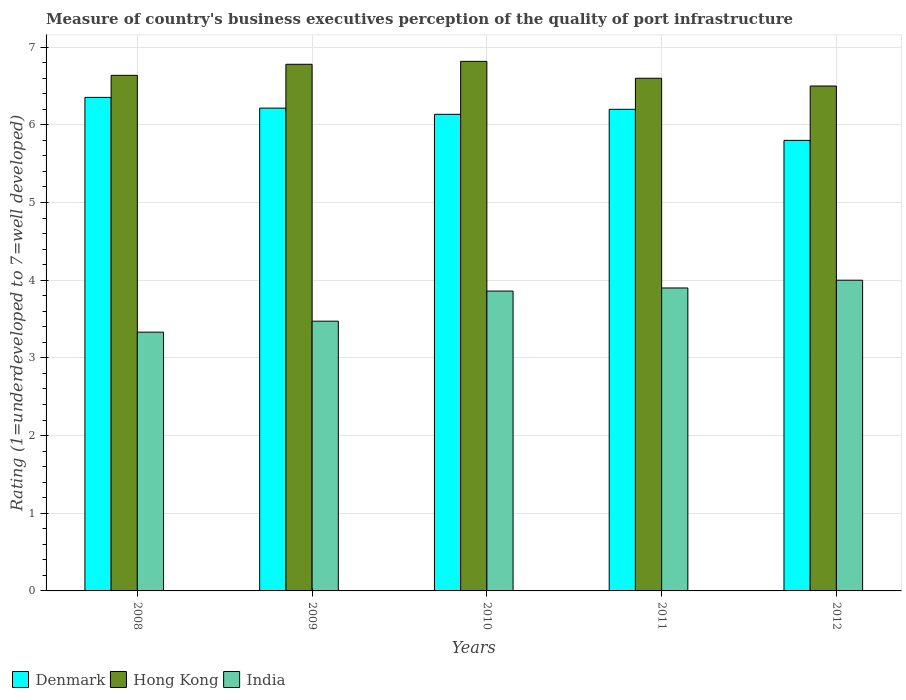How many groups of bars are there?
Make the answer very short. 5. Are the number of bars per tick equal to the number of legend labels?
Provide a succinct answer. Yes. How many bars are there on the 3rd tick from the right?
Make the answer very short. 3. What is the ratings of the quality of port infrastructure in Hong Kong in 2008?
Your answer should be very brief. 6.64. Across all years, what is the maximum ratings of the quality of port infrastructure in Denmark?
Your answer should be compact. 6.35. Across all years, what is the minimum ratings of the quality of port infrastructure in Hong Kong?
Offer a terse response. 6.5. In which year was the ratings of the quality of port infrastructure in Denmark maximum?
Make the answer very short. 2008. What is the total ratings of the quality of port infrastructure in Denmark in the graph?
Ensure brevity in your answer.  30.7. What is the difference between the ratings of the quality of port infrastructure in Denmark in 2008 and that in 2011?
Your answer should be very brief. 0.15. What is the difference between the ratings of the quality of port infrastructure in Denmark in 2009 and the ratings of the quality of port infrastructure in Hong Kong in 2012?
Keep it short and to the point. -0.28. What is the average ratings of the quality of port infrastructure in Hong Kong per year?
Make the answer very short. 6.67. In the year 2011, what is the difference between the ratings of the quality of port infrastructure in Hong Kong and ratings of the quality of port infrastructure in India?
Your response must be concise. 2.7. In how many years, is the ratings of the quality of port infrastructure in India greater than 2?
Keep it short and to the point. 5. What is the ratio of the ratings of the quality of port infrastructure in Hong Kong in 2009 to that in 2012?
Ensure brevity in your answer.  1.04. Is the ratings of the quality of port infrastructure in Hong Kong in 2011 less than that in 2012?
Make the answer very short. No. Is the difference between the ratings of the quality of port infrastructure in Hong Kong in 2008 and 2010 greater than the difference between the ratings of the quality of port infrastructure in India in 2008 and 2010?
Provide a short and direct response. Yes. What is the difference between the highest and the second highest ratings of the quality of port infrastructure in Hong Kong?
Offer a terse response. 0.04. What is the difference between the highest and the lowest ratings of the quality of port infrastructure in India?
Your answer should be compact. 0.67. What does the 1st bar from the left in 2009 represents?
Ensure brevity in your answer.  Denmark. What does the 1st bar from the right in 2012 represents?
Offer a terse response. India. Is it the case that in every year, the sum of the ratings of the quality of port infrastructure in Denmark and ratings of the quality of port infrastructure in Hong Kong is greater than the ratings of the quality of port infrastructure in India?
Your response must be concise. Yes. Are all the bars in the graph horizontal?
Your response must be concise. No. How many years are there in the graph?
Provide a short and direct response. 5. Does the graph contain any zero values?
Ensure brevity in your answer.  No. Does the graph contain grids?
Offer a terse response. Yes. Where does the legend appear in the graph?
Keep it short and to the point. Bottom left. What is the title of the graph?
Offer a terse response. Measure of country's business executives perception of the quality of port infrastructure. Does "High income: nonOECD" appear as one of the legend labels in the graph?
Make the answer very short. No. What is the label or title of the X-axis?
Your answer should be very brief. Years. What is the label or title of the Y-axis?
Ensure brevity in your answer.  Rating (1=underdeveloped to 7=well developed). What is the Rating (1=underdeveloped to 7=well developed) in Denmark in 2008?
Offer a terse response. 6.35. What is the Rating (1=underdeveloped to 7=well developed) in Hong Kong in 2008?
Your response must be concise. 6.64. What is the Rating (1=underdeveloped to 7=well developed) in India in 2008?
Give a very brief answer. 3.33. What is the Rating (1=underdeveloped to 7=well developed) in Denmark in 2009?
Ensure brevity in your answer.  6.22. What is the Rating (1=underdeveloped to 7=well developed) of Hong Kong in 2009?
Offer a very short reply. 6.78. What is the Rating (1=underdeveloped to 7=well developed) of India in 2009?
Keep it short and to the point. 3.47. What is the Rating (1=underdeveloped to 7=well developed) in Denmark in 2010?
Provide a succinct answer. 6.14. What is the Rating (1=underdeveloped to 7=well developed) of Hong Kong in 2010?
Make the answer very short. 6.82. What is the Rating (1=underdeveloped to 7=well developed) of India in 2010?
Keep it short and to the point. 3.86. What is the Rating (1=underdeveloped to 7=well developed) in Denmark in 2011?
Make the answer very short. 6.2. What is the Rating (1=underdeveloped to 7=well developed) of India in 2011?
Offer a terse response. 3.9. Across all years, what is the maximum Rating (1=underdeveloped to 7=well developed) of Denmark?
Your response must be concise. 6.35. Across all years, what is the maximum Rating (1=underdeveloped to 7=well developed) in Hong Kong?
Your response must be concise. 6.82. Across all years, what is the minimum Rating (1=underdeveloped to 7=well developed) in India?
Give a very brief answer. 3.33. What is the total Rating (1=underdeveloped to 7=well developed) of Denmark in the graph?
Give a very brief answer. 30.7. What is the total Rating (1=underdeveloped to 7=well developed) in Hong Kong in the graph?
Provide a succinct answer. 33.33. What is the total Rating (1=underdeveloped to 7=well developed) of India in the graph?
Your answer should be very brief. 18.56. What is the difference between the Rating (1=underdeveloped to 7=well developed) in Denmark in 2008 and that in 2009?
Your response must be concise. 0.14. What is the difference between the Rating (1=underdeveloped to 7=well developed) of Hong Kong in 2008 and that in 2009?
Offer a very short reply. -0.14. What is the difference between the Rating (1=underdeveloped to 7=well developed) of India in 2008 and that in 2009?
Offer a terse response. -0.14. What is the difference between the Rating (1=underdeveloped to 7=well developed) in Denmark in 2008 and that in 2010?
Make the answer very short. 0.22. What is the difference between the Rating (1=underdeveloped to 7=well developed) in Hong Kong in 2008 and that in 2010?
Offer a very short reply. -0.18. What is the difference between the Rating (1=underdeveloped to 7=well developed) in India in 2008 and that in 2010?
Your answer should be compact. -0.53. What is the difference between the Rating (1=underdeveloped to 7=well developed) in Denmark in 2008 and that in 2011?
Your answer should be very brief. 0.15. What is the difference between the Rating (1=underdeveloped to 7=well developed) of Hong Kong in 2008 and that in 2011?
Your answer should be compact. 0.04. What is the difference between the Rating (1=underdeveloped to 7=well developed) of India in 2008 and that in 2011?
Ensure brevity in your answer.  -0.57. What is the difference between the Rating (1=underdeveloped to 7=well developed) in Denmark in 2008 and that in 2012?
Ensure brevity in your answer.  0.55. What is the difference between the Rating (1=underdeveloped to 7=well developed) of Hong Kong in 2008 and that in 2012?
Make the answer very short. 0.14. What is the difference between the Rating (1=underdeveloped to 7=well developed) of India in 2008 and that in 2012?
Offer a terse response. -0.67. What is the difference between the Rating (1=underdeveloped to 7=well developed) in Denmark in 2009 and that in 2010?
Provide a short and direct response. 0.08. What is the difference between the Rating (1=underdeveloped to 7=well developed) in Hong Kong in 2009 and that in 2010?
Provide a succinct answer. -0.04. What is the difference between the Rating (1=underdeveloped to 7=well developed) of India in 2009 and that in 2010?
Your answer should be compact. -0.39. What is the difference between the Rating (1=underdeveloped to 7=well developed) in Denmark in 2009 and that in 2011?
Ensure brevity in your answer.  0.02. What is the difference between the Rating (1=underdeveloped to 7=well developed) in Hong Kong in 2009 and that in 2011?
Make the answer very short. 0.18. What is the difference between the Rating (1=underdeveloped to 7=well developed) in India in 2009 and that in 2011?
Make the answer very short. -0.43. What is the difference between the Rating (1=underdeveloped to 7=well developed) in Denmark in 2009 and that in 2012?
Provide a succinct answer. 0.42. What is the difference between the Rating (1=underdeveloped to 7=well developed) in Hong Kong in 2009 and that in 2012?
Your answer should be very brief. 0.28. What is the difference between the Rating (1=underdeveloped to 7=well developed) of India in 2009 and that in 2012?
Ensure brevity in your answer.  -0.53. What is the difference between the Rating (1=underdeveloped to 7=well developed) in Denmark in 2010 and that in 2011?
Give a very brief answer. -0.06. What is the difference between the Rating (1=underdeveloped to 7=well developed) in Hong Kong in 2010 and that in 2011?
Your answer should be compact. 0.22. What is the difference between the Rating (1=underdeveloped to 7=well developed) in India in 2010 and that in 2011?
Give a very brief answer. -0.04. What is the difference between the Rating (1=underdeveloped to 7=well developed) in Denmark in 2010 and that in 2012?
Offer a terse response. 0.34. What is the difference between the Rating (1=underdeveloped to 7=well developed) of Hong Kong in 2010 and that in 2012?
Make the answer very short. 0.32. What is the difference between the Rating (1=underdeveloped to 7=well developed) in India in 2010 and that in 2012?
Offer a very short reply. -0.14. What is the difference between the Rating (1=underdeveloped to 7=well developed) of Denmark in 2011 and that in 2012?
Offer a very short reply. 0.4. What is the difference between the Rating (1=underdeveloped to 7=well developed) in India in 2011 and that in 2012?
Offer a very short reply. -0.1. What is the difference between the Rating (1=underdeveloped to 7=well developed) of Denmark in 2008 and the Rating (1=underdeveloped to 7=well developed) of Hong Kong in 2009?
Your answer should be very brief. -0.43. What is the difference between the Rating (1=underdeveloped to 7=well developed) in Denmark in 2008 and the Rating (1=underdeveloped to 7=well developed) in India in 2009?
Keep it short and to the point. 2.88. What is the difference between the Rating (1=underdeveloped to 7=well developed) in Hong Kong in 2008 and the Rating (1=underdeveloped to 7=well developed) in India in 2009?
Provide a succinct answer. 3.16. What is the difference between the Rating (1=underdeveloped to 7=well developed) in Denmark in 2008 and the Rating (1=underdeveloped to 7=well developed) in Hong Kong in 2010?
Ensure brevity in your answer.  -0.46. What is the difference between the Rating (1=underdeveloped to 7=well developed) of Denmark in 2008 and the Rating (1=underdeveloped to 7=well developed) of India in 2010?
Your answer should be compact. 2.49. What is the difference between the Rating (1=underdeveloped to 7=well developed) of Hong Kong in 2008 and the Rating (1=underdeveloped to 7=well developed) of India in 2010?
Offer a very short reply. 2.78. What is the difference between the Rating (1=underdeveloped to 7=well developed) of Denmark in 2008 and the Rating (1=underdeveloped to 7=well developed) of Hong Kong in 2011?
Provide a short and direct response. -0.25. What is the difference between the Rating (1=underdeveloped to 7=well developed) in Denmark in 2008 and the Rating (1=underdeveloped to 7=well developed) in India in 2011?
Your answer should be very brief. 2.45. What is the difference between the Rating (1=underdeveloped to 7=well developed) in Hong Kong in 2008 and the Rating (1=underdeveloped to 7=well developed) in India in 2011?
Your answer should be very brief. 2.74. What is the difference between the Rating (1=underdeveloped to 7=well developed) in Denmark in 2008 and the Rating (1=underdeveloped to 7=well developed) in Hong Kong in 2012?
Provide a short and direct response. -0.15. What is the difference between the Rating (1=underdeveloped to 7=well developed) of Denmark in 2008 and the Rating (1=underdeveloped to 7=well developed) of India in 2012?
Keep it short and to the point. 2.35. What is the difference between the Rating (1=underdeveloped to 7=well developed) of Hong Kong in 2008 and the Rating (1=underdeveloped to 7=well developed) of India in 2012?
Your answer should be compact. 2.64. What is the difference between the Rating (1=underdeveloped to 7=well developed) in Denmark in 2009 and the Rating (1=underdeveloped to 7=well developed) in Hong Kong in 2010?
Keep it short and to the point. -0.6. What is the difference between the Rating (1=underdeveloped to 7=well developed) in Denmark in 2009 and the Rating (1=underdeveloped to 7=well developed) in India in 2010?
Your response must be concise. 2.35. What is the difference between the Rating (1=underdeveloped to 7=well developed) of Hong Kong in 2009 and the Rating (1=underdeveloped to 7=well developed) of India in 2010?
Your answer should be very brief. 2.92. What is the difference between the Rating (1=underdeveloped to 7=well developed) in Denmark in 2009 and the Rating (1=underdeveloped to 7=well developed) in Hong Kong in 2011?
Make the answer very short. -0.38. What is the difference between the Rating (1=underdeveloped to 7=well developed) of Denmark in 2009 and the Rating (1=underdeveloped to 7=well developed) of India in 2011?
Provide a succinct answer. 2.32. What is the difference between the Rating (1=underdeveloped to 7=well developed) in Hong Kong in 2009 and the Rating (1=underdeveloped to 7=well developed) in India in 2011?
Your response must be concise. 2.88. What is the difference between the Rating (1=underdeveloped to 7=well developed) in Denmark in 2009 and the Rating (1=underdeveloped to 7=well developed) in Hong Kong in 2012?
Provide a succinct answer. -0.28. What is the difference between the Rating (1=underdeveloped to 7=well developed) in Denmark in 2009 and the Rating (1=underdeveloped to 7=well developed) in India in 2012?
Your response must be concise. 2.22. What is the difference between the Rating (1=underdeveloped to 7=well developed) of Hong Kong in 2009 and the Rating (1=underdeveloped to 7=well developed) of India in 2012?
Your answer should be compact. 2.78. What is the difference between the Rating (1=underdeveloped to 7=well developed) in Denmark in 2010 and the Rating (1=underdeveloped to 7=well developed) in Hong Kong in 2011?
Offer a terse response. -0.46. What is the difference between the Rating (1=underdeveloped to 7=well developed) in Denmark in 2010 and the Rating (1=underdeveloped to 7=well developed) in India in 2011?
Keep it short and to the point. 2.24. What is the difference between the Rating (1=underdeveloped to 7=well developed) in Hong Kong in 2010 and the Rating (1=underdeveloped to 7=well developed) in India in 2011?
Ensure brevity in your answer.  2.92. What is the difference between the Rating (1=underdeveloped to 7=well developed) of Denmark in 2010 and the Rating (1=underdeveloped to 7=well developed) of Hong Kong in 2012?
Offer a very short reply. -0.36. What is the difference between the Rating (1=underdeveloped to 7=well developed) in Denmark in 2010 and the Rating (1=underdeveloped to 7=well developed) in India in 2012?
Your answer should be very brief. 2.14. What is the difference between the Rating (1=underdeveloped to 7=well developed) of Hong Kong in 2010 and the Rating (1=underdeveloped to 7=well developed) of India in 2012?
Ensure brevity in your answer.  2.82. What is the difference between the Rating (1=underdeveloped to 7=well developed) in Denmark in 2011 and the Rating (1=underdeveloped to 7=well developed) in India in 2012?
Your answer should be very brief. 2.2. What is the difference between the Rating (1=underdeveloped to 7=well developed) in Hong Kong in 2011 and the Rating (1=underdeveloped to 7=well developed) in India in 2012?
Make the answer very short. 2.6. What is the average Rating (1=underdeveloped to 7=well developed) of Denmark per year?
Your response must be concise. 6.14. What is the average Rating (1=underdeveloped to 7=well developed) in Hong Kong per year?
Provide a succinct answer. 6.67. What is the average Rating (1=underdeveloped to 7=well developed) in India per year?
Offer a very short reply. 3.71. In the year 2008, what is the difference between the Rating (1=underdeveloped to 7=well developed) of Denmark and Rating (1=underdeveloped to 7=well developed) of Hong Kong?
Ensure brevity in your answer.  -0.28. In the year 2008, what is the difference between the Rating (1=underdeveloped to 7=well developed) of Denmark and Rating (1=underdeveloped to 7=well developed) of India?
Your answer should be compact. 3.02. In the year 2008, what is the difference between the Rating (1=underdeveloped to 7=well developed) of Hong Kong and Rating (1=underdeveloped to 7=well developed) of India?
Your answer should be compact. 3.31. In the year 2009, what is the difference between the Rating (1=underdeveloped to 7=well developed) in Denmark and Rating (1=underdeveloped to 7=well developed) in Hong Kong?
Give a very brief answer. -0.56. In the year 2009, what is the difference between the Rating (1=underdeveloped to 7=well developed) in Denmark and Rating (1=underdeveloped to 7=well developed) in India?
Give a very brief answer. 2.74. In the year 2009, what is the difference between the Rating (1=underdeveloped to 7=well developed) in Hong Kong and Rating (1=underdeveloped to 7=well developed) in India?
Provide a succinct answer. 3.31. In the year 2010, what is the difference between the Rating (1=underdeveloped to 7=well developed) in Denmark and Rating (1=underdeveloped to 7=well developed) in Hong Kong?
Your response must be concise. -0.68. In the year 2010, what is the difference between the Rating (1=underdeveloped to 7=well developed) of Denmark and Rating (1=underdeveloped to 7=well developed) of India?
Offer a terse response. 2.28. In the year 2010, what is the difference between the Rating (1=underdeveloped to 7=well developed) of Hong Kong and Rating (1=underdeveloped to 7=well developed) of India?
Your answer should be very brief. 2.96. In the year 2011, what is the difference between the Rating (1=underdeveloped to 7=well developed) in Denmark and Rating (1=underdeveloped to 7=well developed) in India?
Your answer should be compact. 2.3. In the year 2011, what is the difference between the Rating (1=underdeveloped to 7=well developed) of Hong Kong and Rating (1=underdeveloped to 7=well developed) of India?
Your response must be concise. 2.7. What is the ratio of the Rating (1=underdeveloped to 7=well developed) of Denmark in 2008 to that in 2009?
Give a very brief answer. 1.02. What is the ratio of the Rating (1=underdeveloped to 7=well developed) of Hong Kong in 2008 to that in 2009?
Your response must be concise. 0.98. What is the ratio of the Rating (1=underdeveloped to 7=well developed) in India in 2008 to that in 2009?
Provide a succinct answer. 0.96. What is the ratio of the Rating (1=underdeveloped to 7=well developed) in Denmark in 2008 to that in 2010?
Make the answer very short. 1.04. What is the ratio of the Rating (1=underdeveloped to 7=well developed) of Hong Kong in 2008 to that in 2010?
Keep it short and to the point. 0.97. What is the ratio of the Rating (1=underdeveloped to 7=well developed) of India in 2008 to that in 2010?
Your answer should be very brief. 0.86. What is the ratio of the Rating (1=underdeveloped to 7=well developed) of Denmark in 2008 to that in 2011?
Your answer should be compact. 1.02. What is the ratio of the Rating (1=underdeveloped to 7=well developed) in Hong Kong in 2008 to that in 2011?
Offer a terse response. 1.01. What is the ratio of the Rating (1=underdeveloped to 7=well developed) of India in 2008 to that in 2011?
Give a very brief answer. 0.85. What is the ratio of the Rating (1=underdeveloped to 7=well developed) of Denmark in 2008 to that in 2012?
Provide a short and direct response. 1.1. What is the ratio of the Rating (1=underdeveloped to 7=well developed) of Hong Kong in 2008 to that in 2012?
Make the answer very short. 1.02. What is the ratio of the Rating (1=underdeveloped to 7=well developed) in India in 2008 to that in 2012?
Your answer should be very brief. 0.83. What is the ratio of the Rating (1=underdeveloped to 7=well developed) in Denmark in 2009 to that in 2010?
Provide a short and direct response. 1.01. What is the ratio of the Rating (1=underdeveloped to 7=well developed) of Hong Kong in 2009 to that in 2010?
Your answer should be compact. 0.99. What is the ratio of the Rating (1=underdeveloped to 7=well developed) in India in 2009 to that in 2010?
Make the answer very short. 0.9. What is the ratio of the Rating (1=underdeveloped to 7=well developed) in Denmark in 2009 to that in 2011?
Your answer should be compact. 1. What is the ratio of the Rating (1=underdeveloped to 7=well developed) of Hong Kong in 2009 to that in 2011?
Give a very brief answer. 1.03. What is the ratio of the Rating (1=underdeveloped to 7=well developed) in India in 2009 to that in 2011?
Provide a succinct answer. 0.89. What is the ratio of the Rating (1=underdeveloped to 7=well developed) in Denmark in 2009 to that in 2012?
Ensure brevity in your answer.  1.07. What is the ratio of the Rating (1=underdeveloped to 7=well developed) of Hong Kong in 2009 to that in 2012?
Ensure brevity in your answer.  1.04. What is the ratio of the Rating (1=underdeveloped to 7=well developed) of India in 2009 to that in 2012?
Ensure brevity in your answer.  0.87. What is the ratio of the Rating (1=underdeveloped to 7=well developed) of Hong Kong in 2010 to that in 2011?
Offer a terse response. 1.03. What is the ratio of the Rating (1=underdeveloped to 7=well developed) in Denmark in 2010 to that in 2012?
Your response must be concise. 1.06. What is the ratio of the Rating (1=underdeveloped to 7=well developed) of Hong Kong in 2010 to that in 2012?
Keep it short and to the point. 1.05. What is the ratio of the Rating (1=underdeveloped to 7=well developed) in India in 2010 to that in 2012?
Give a very brief answer. 0.97. What is the ratio of the Rating (1=underdeveloped to 7=well developed) in Denmark in 2011 to that in 2012?
Offer a terse response. 1.07. What is the ratio of the Rating (1=underdeveloped to 7=well developed) in Hong Kong in 2011 to that in 2012?
Offer a terse response. 1.02. What is the difference between the highest and the second highest Rating (1=underdeveloped to 7=well developed) of Denmark?
Your answer should be very brief. 0.14. What is the difference between the highest and the second highest Rating (1=underdeveloped to 7=well developed) in Hong Kong?
Make the answer very short. 0.04. What is the difference between the highest and the second highest Rating (1=underdeveloped to 7=well developed) of India?
Make the answer very short. 0.1. What is the difference between the highest and the lowest Rating (1=underdeveloped to 7=well developed) of Denmark?
Ensure brevity in your answer.  0.55. What is the difference between the highest and the lowest Rating (1=underdeveloped to 7=well developed) of Hong Kong?
Provide a short and direct response. 0.32. What is the difference between the highest and the lowest Rating (1=underdeveloped to 7=well developed) of India?
Give a very brief answer. 0.67. 